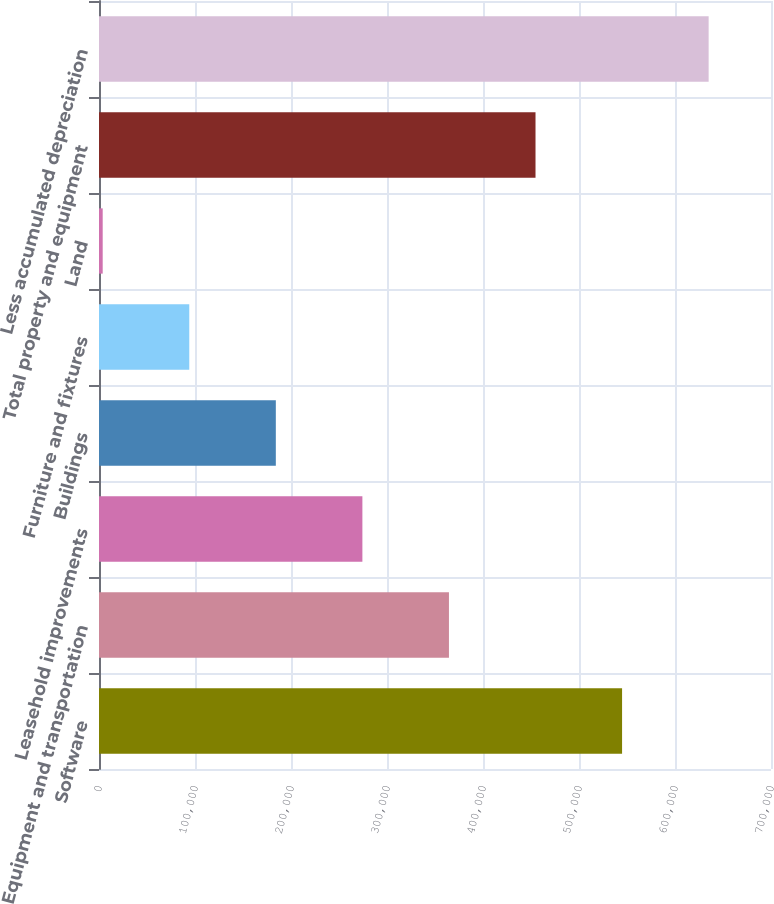Convert chart to OTSL. <chart><loc_0><loc_0><loc_500><loc_500><bar_chart><fcel>Software<fcel>Equipment and transportation<fcel>Leasehold improvements<fcel>Buildings<fcel>Furniture and fixtures<fcel>Land<fcel>Total property and equipment<fcel>Less accumulated depreciation<nl><fcel>544871<fcel>364531<fcel>274362<fcel>184192<fcel>94022.6<fcel>3853<fcel>454701<fcel>635040<nl></chart> 